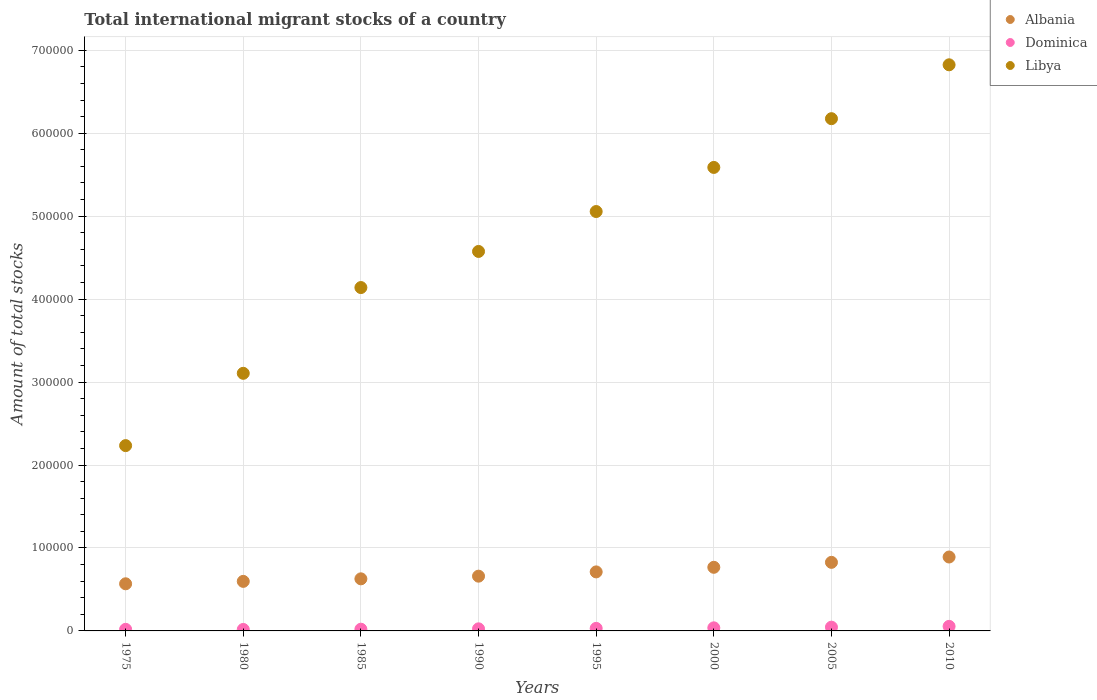How many different coloured dotlines are there?
Your answer should be compact. 3. What is the amount of total stocks in in Albania in 2000?
Offer a terse response. 7.67e+04. Across all years, what is the maximum amount of total stocks in in Albania?
Give a very brief answer. 8.91e+04. Across all years, what is the minimum amount of total stocks in in Albania?
Your answer should be very brief. 5.68e+04. In which year was the amount of total stocks in in Dominica maximum?
Ensure brevity in your answer.  2010. What is the total amount of total stocks in in Dominica in the graph?
Offer a terse response. 2.51e+04. What is the difference between the amount of total stocks in in Albania in 1975 and that in 1980?
Make the answer very short. -2914. What is the difference between the amount of total stocks in in Libya in 1985 and the amount of total stocks in in Albania in 1990?
Your response must be concise. 3.48e+05. What is the average amount of total stocks in in Dominica per year?
Your answer should be compact. 3136.75. In the year 1975, what is the difference between the amount of total stocks in in Albania and amount of total stocks in in Libya?
Offer a terse response. -1.67e+05. In how many years, is the amount of total stocks in in Dominica greater than 40000?
Your response must be concise. 0. What is the ratio of the amount of total stocks in in Dominica in 1980 to that in 1995?
Your answer should be very brief. 0.58. Is the amount of total stocks in in Libya in 1980 less than that in 2000?
Provide a short and direct response. Yes. Is the difference between the amount of total stocks in in Albania in 1985 and 2005 greater than the difference between the amount of total stocks in in Libya in 1985 and 2005?
Ensure brevity in your answer.  Yes. What is the difference between the highest and the second highest amount of total stocks in in Dominica?
Give a very brief answer. 975. What is the difference between the highest and the lowest amount of total stocks in in Libya?
Keep it short and to the point. 4.59e+05. Is it the case that in every year, the sum of the amount of total stocks in in Dominica and amount of total stocks in in Libya  is greater than the amount of total stocks in in Albania?
Your answer should be very brief. Yes. Does the amount of total stocks in in Albania monotonically increase over the years?
Offer a very short reply. Yes. Is the amount of total stocks in in Libya strictly greater than the amount of total stocks in in Dominica over the years?
Provide a short and direct response. Yes. Is the amount of total stocks in in Libya strictly less than the amount of total stocks in in Dominica over the years?
Provide a succinct answer. No. Are the values on the major ticks of Y-axis written in scientific E-notation?
Ensure brevity in your answer.  No. Does the graph contain grids?
Offer a terse response. Yes. Where does the legend appear in the graph?
Give a very brief answer. Top right. How many legend labels are there?
Give a very brief answer. 3. What is the title of the graph?
Offer a very short reply. Total international migrant stocks of a country. What is the label or title of the X-axis?
Provide a succinct answer. Years. What is the label or title of the Y-axis?
Your answer should be very brief. Amount of total stocks. What is the Amount of total stocks in Albania in 1975?
Ensure brevity in your answer.  5.68e+04. What is the Amount of total stocks in Dominica in 1975?
Your answer should be very brief. 1913. What is the Amount of total stocks of Libya in 1975?
Keep it short and to the point. 2.23e+05. What is the Amount of total stocks in Albania in 1980?
Ensure brevity in your answer.  5.97e+04. What is the Amount of total stocks of Dominica in 1980?
Provide a succinct answer. 1777. What is the Amount of total stocks in Libya in 1980?
Give a very brief answer. 3.11e+05. What is the Amount of total stocks of Albania in 1985?
Ensure brevity in your answer.  6.28e+04. What is the Amount of total stocks of Dominica in 1985?
Make the answer very short. 2072. What is the Amount of total stocks of Libya in 1985?
Your answer should be very brief. 4.14e+05. What is the Amount of total stocks of Albania in 1990?
Offer a very short reply. 6.60e+04. What is the Amount of total stocks of Dominica in 1990?
Provide a short and direct response. 2519. What is the Amount of total stocks of Libya in 1990?
Provide a succinct answer. 4.57e+05. What is the Amount of total stocks of Albania in 1995?
Your answer should be very brief. 7.12e+04. What is the Amount of total stocks of Dominica in 1995?
Provide a short and direct response. 3063. What is the Amount of total stocks in Libya in 1995?
Ensure brevity in your answer.  5.06e+05. What is the Amount of total stocks in Albania in 2000?
Give a very brief answer. 7.67e+04. What is the Amount of total stocks of Dominica in 2000?
Your answer should be compact. 3723. What is the Amount of total stocks in Libya in 2000?
Your answer should be compact. 5.59e+05. What is the Amount of total stocks in Albania in 2005?
Offer a very short reply. 8.27e+04. What is the Amount of total stocks in Dominica in 2005?
Provide a short and direct response. 4526. What is the Amount of total stocks of Libya in 2005?
Your answer should be compact. 6.18e+05. What is the Amount of total stocks of Albania in 2010?
Provide a short and direct response. 8.91e+04. What is the Amount of total stocks of Dominica in 2010?
Give a very brief answer. 5501. What is the Amount of total stocks of Libya in 2010?
Make the answer very short. 6.82e+05. Across all years, what is the maximum Amount of total stocks of Albania?
Provide a succinct answer. 8.91e+04. Across all years, what is the maximum Amount of total stocks of Dominica?
Your answer should be very brief. 5501. Across all years, what is the maximum Amount of total stocks of Libya?
Offer a very short reply. 6.82e+05. Across all years, what is the minimum Amount of total stocks in Albania?
Your response must be concise. 5.68e+04. Across all years, what is the minimum Amount of total stocks of Dominica?
Give a very brief answer. 1777. Across all years, what is the minimum Amount of total stocks of Libya?
Your answer should be compact. 2.23e+05. What is the total Amount of total stocks of Albania in the graph?
Give a very brief answer. 5.65e+05. What is the total Amount of total stocks in Dominica in the graph?
Your answer should be very brief. 2.51e+04. What is the total Amount of total stocks of Libya in the graph?
Provide a succinct answer. 3.77e+06. What is the difference between the Amount of total stocks of Albania in 1975 and that in 1980?
Ensure brevity in your answer.  -2914. What is the difference between the Amount of total stocks in Dominica in 1975 and that in 1980?
Your answer should be compact. 136. What is the difference between the Amount of total stocks of Libya in 1975 and that in 1980?
Your answer should be compact. -8.72e+04. What is the difference between the Amount of total stocks of Albania in 1975 and that in 1985?
Ensure brevity in your answer.  -5977. What is the difference between the Amount of total stocks in Dominica in 1975 and that in 1985?
Give a very brief answer. -159. What is the difference between the Amount of total stocks of Libya in 1975 and that in 1985?
Your answer should be compact. -1.91e+05. What is the difference between the Amount of total stocks in Albania in 1975 and that in 1990?
Offer a very short reply. -9197. What is the difference between the Amount of total stocks in Dominica in 1975 and that in 1990?
Your answer should be compact. -606. What is the difference between the Amount of total stocks in Libya in 1975 and that in 1990?
Your answer should be very brief. -2.34e+05. What is the difference between the Amount of total stocks of Albania in 1975 and that in 1995?
Provide a succinct answer. -1.43e+04. What is the difference between the Amount of total stocks in Dominica in 1975 and that in 1995?
Keep it short and to the point. -1150. What is the difference between the Amount of total stocks of Libya in 1975 and that in 1995?
Provide a succinct answer. -2.82e+05. What is the difference between the Amount of total stocks of Albania in 1975 and that in 2000?
Give a very brief answer. -1.99e+04. What is the difference between the Amount of total stocks of Dominica in 1975 and that in 2000?
Give a very brief answer. -1810. What is the difference between the Amount of total stocks in Libya in 1975 and that in 2000?
Offer a terse response. -3.35e+05. What is the difference between the Amount of total stocks of Albania in 1975 and that in 2005?
Your answer should be very brief. -2.59e+04. What is the difference between the Amount of total stocks in Dominica in 1975 and that in 2005?
Give a very brief answer. -2613. What is the difference between the Amount of total stocks of Libya in 1975 and that in 2005?
Give a very brief answer. -3.94e+05. What is the difference between the Amount of total stocks in Albania in 1975 and that in 2010?
Ensure brevity in your answer.  -3.23e+04. What is the difference between the Amount of total stocks of Dominica in 1975 and that in 2010?
Provide a succinct answer. -3588. What is the difference between the Amount of total stocks in Libya in 1975 and that in 2010?
Provide a succinct answer. -4.59e+05. What is the difference between the Amount of total stocks in Albania in 1980 and that in 1985?
Your response must be concise. -3063. What is the difference between the Amount of total stocks in Dominica in 1980 and that in 1985?
Your answer should be very brief. -295. What is the difference between the Amount of total stocks of Libya in 1980 and that in 1985?
Keep it short and to the point. -1.03e+05. What is the difference between the Amount of total stocks of Albania in 1980 and that in 1990?
Keep it short and to the point. -6283. What is the difference between the Amount of total stocks of Dominica in 1980 and that in 1990?
Offer a very short reply. -742. What is the difference between the Amount of total stocks of Libya in 1980 and that in 1990?
Make the answer very short. -1.47e+05. What is the difference between the Amount of total stocks of Albania in 1980 and that in 1995?
Your response must be concise. -1.14e+04. What is the difference between the Amount of total stocks in Dominica in 1980 and that in 1995?
Keep it short and to the point. -1286. What is the difference between the Amount of total stocks in Libya in 1980 and that in 1995?
Offer a terse response. -1.95e+05. What is the difference between the Amount of total stocks of Albania in 1980 and that in 2000?
Ensure brevity in your answer.  -1.70e+04. What is the difference between the Amount of total stocks in Dominica in 1980 and that in 2000?
Your answer should be very brief. -1946. What is the difference between the Amount of total stocks of Libya in 1980 and that in 2000?
Ensure brevity in your answer.  -2.48e+05. What is the difference between the Amount of total stocks of Albania in 1980 and that in 2005?
Keep it short and to the point. -2.29e+04. What is the difference between the Amount of total stocks in Dominica in 1980 and that in 2005?
Your answer should be compact. -2749. What is the difference between the Amount of total stocks of Libya in 1980 and that in 2005?
Give a very brief answer. -3.07e+05. What is the difference between the Amount of total stocks in Albania in 1980 and that in 2010?
Your answer should be very brief. -2.94e+04. What is the difference between the Amount of total stocks in Dominica in 1980 and that in 2010?
Make the answer very short. -3724. What is the difference between the Amount of total stocks of Libya in 1980 and that in 2010?
Your response must be concise. -3.72e+05. What is the difference between the Amount of total stocks in Albania in 1985 and that in 1990?
Ensure brevity in your answer.  -3220. What is the difference between the Amount of total stocks of Dominica in 1985 and that in 1990?
Give a very brief answer. -447. What is the difference between the Amount of total stocks in Libya in 1985 and that in 1990?
Your answer should be compact. -4.35e+04. What is the difference between the Amount of total stocks in Albania in 1985 and that in 1995?
Provide a short and direct response. -8361. What is the difference between the Amount of total stocks of Dominica in 1985 and that in 1995?
Make the answer very short. -991. What is the difference between the Amount of total stocks in Libya in 1985 and that in 1995?
Offer a terse response. -9.16e+04. What is the difference between the Amount of total stocks of Albania in 1985 and that in 2000?
Your response must be concise. -1.39e+04. What is the difference between the Amount of total stocks of Dominica in 1985 and that in 2000?
Your answer should be very brief. -1651. What is the difference between the Amount of total stocks of Libya in 1985 and that in 2000?
Your answer should be very brief. -1.45e+05. What is the difference between the Amount of total stocks in Albania in 1985 and that in 2005?
Provide a short and direct response. -1.99e+04. What is the difference between the Amount of total stocks in Dominica in 1985 and that in 2005?
Your answer should be very brief. -2454. What is the difference between the Amount of total stocks of Libya in 1985 and that in 2005?
Your answer should be compact. -2.04e+05. What is the difference between the Amount of total stocks in Albania in 1985 and that in 2010?
Keep it short and to the point. -2.63e+04. What is the difference between the Amount of total stocks of Dominica in 1985 and that in 2010?
Your answer should be very brief. -3429. What is the difference between the Amount of total stocks of Libya in 1985 and that in 2010?
Your response must be concise. -2.69e+05. What is the difference between the Amount of total stocks of Albania in 1990 and that in 1995?
Provide a short and direct response. -5141. What is the difference between the Amount of total stocks in Dominica in 1990 and that in 1995?
Your response must be concise. -544. What is the difference between the Amount of total stocks in Libya in 1990 and that in 1995?
Make the answer very short. -4.81e+04. What is the difference between the Amount of total stocks in Albania in 1990 and that in 2000?
Offer a terse response. -1.07e+04. What is the difference between the Amount of total stocks in Dominica in 1990 and that in 2000?
Offer a terse response. -1204. What is the difference between the Amount of total stocks in Libya in 1990 and that in 2000?
Give a very brief answer. -1.01e+05. What is the difference between the Amount of total stocks in Albania in 1990 and that in 2005?
Ensure brevity in your answer.  -1.67e+04. What is the difference between the Amount of total stocks in Dominica in 1990 and that in 2005?
Keep it short and to the point. -2007. What is the difference between the Amount of total stocks of Libya in 1990 and that in 2005?
Ensure brevity in your answer.  -1.60e+05. What is the difference between the Amount of total stocks in Albania in 1990 and that in 2010?
Ensure brevity in your answer.  -2.31e+04. What is the difference between the Amount of total stocks of Dominica in 1990 and that in 2010?
Offer a terse response. -2982. What is the difference between the Amount of total stocks of Libya in 1990 and that in 2010?
Your response must be concise. -2.25e+05. What is the difference between the Amount of total stocks of Albania in 1995 and that in 2000?
Provide a short and direct response. -5541. What is the difference between the Amount of total stocks in Dominica in 1995 and that in 2000?
Make the answer very short. -660. What is the difference between the Amount of total stocks of Libya in 1995 and that in 2000?
Keep it short and to the point. -5.32e+04. What is the difference between the Amount of total stocks of Albania in 1995 and that in 2005?
Make the answer very short. -1.15e+04. What is the difference between the Amount of total stocks of Dominica in 1995 and that in 2005?
Offer a terse response. -1463. What is the difference between the Amount of total stocks of Libya in 1995 and that in 2005?
Ensure brevity in your answer.  -1.12e+05. What is the difference between the Amount of total stocks of Albania in 1995 and that in 2010?
Your answer should be very brief. -1.80e+04. What is the difference between the Amount of total stocks in Dominica in 1995 and that in 2010?
Make the answer very short. -2438. What is the difference between the Amount of total stocks in Libya in 1995 and that in 2010?
Provide a succinct answer. -1.77e+05. What is the difference between the Amount of total stocks in Albania in 2000 and that in 2005?
Offer a terse response. -5973. What is the difference between the Amount of total stocks of Dominica in 2000 and that in 2005?
Keep it short and to the point. -803. What is the difference between the Amount of total stocks of Libya in 2000 and that in 2005?
Provide a short and direct response. -5.88e+04. What is the difference between the Amount of total stocks of Albania in 2000 and that in 2010?
Offer a very short reply. -1.24e+04. What is the difference between the Amount of total stocks in Dominica in 2000 and that in 2010?
Make the answer very short. -1778. What is the difference between the Amount of total stocks in Libya in 2000 and that in 2010?
Offer a terse response. -1.24e+05. What is the difference between the Amount of total stocks of Albania in 2005 and that in 2010?
Give a very brief answer. -6438. What is the difference between the Amount of total stocks in Dominica in 2005 and that in 2010?
Make the answer very short. -975. What is the difference between the Amount of total stocks in Libya in 2005 and that in 2010?
Give a very brief answer. -6.49e+04. What is the difference between the Amount of total stocks of Albania in 1975 and the Amount of total stocks of Dominica in 1980?
Ensure brevity in your answer.  5.50e+04. What is the difference between the Amount of total stocks of Albania in 1975 and the Amount of total stocks of Libya in 1980?
Your response must be concise. -2.54e+05. What is the difference between the Amount of total stocks of Dominica in 1975 and the Amount of total stocks of Libya in 1980?
Provide a succinct answer. -3.09e+05. What is the difference between the Amount of total stocks of Albania in 1975 and the Amount of total stocks of Dominica in 1985?
Your response must be concise. 5.47e+04. What is the difference between the Amount of total stocks of Albania in 1975 and the Amount of total stocks of Libya in 1985?
Offer a terse response. -3.57e+05. What is the difference between the Amount of total stocks in Dominica in 1975 and the Amount of total stocks in Libya in 1985?
Offer a very short reply. -4.12e+05. What is the difference between the Amount of total stocks in Albania in 1975 and the Amount of total stocks in Dominica in 1990?
Your answer should be compact. 5.43e+04. What is the difference between the Amount of total stocks in Albania in 1975 and the Amount of total stocks in Libya in 1990?
Give a very brief answer. -4.01e+05. What is the difference between the Amount of total stocks of Dominica in 1975 and the Amount of total stocks of Libya in 1990?
Give a very brief answer. -4.56e+05. What is the difference between the Amount of total stocks of Albania in 1975 and the Amount of total stocks of Dominica in 1995?
Your answer should be compact. 5.38e+04. What is the difference between the Amount of total stocks of Albania in 1975 and the Amount of total stocks of Libya in 1995?
Offer a very short reply. -4.49e+05. What is the difference between the Amount of total stocks of Dominica in 1975 and the Amount of total stocks of Libya in 1995?
Your response must be concise. -5.04e+05. What is the difference between the Amount of total stocks in Albania in 1975 and the Amount of total stocks in Dominica in 2000?
Your answer should be very brief. 5.31e+04. What is the difference between the Amount of total stocks in Albania in 1975 and the Amount of total stocks in Libya in 2000?
Make the answer very short. -5.02e+05. What is the difference between the Amount of total stocks of Dominica in 1975 and the Amount of total stocks of Libya in 2000?
Make the answer very short. -5.57e+05. What is the difference between the Amount of total stocks in Albania in 1975 and the Amount of total stocks in Dominica in 2005?
Provide a short and direct response. 5.23e+04. What is the difference between the Amount of total stocks of Albania in 1975 and the Amount of total stocks of Libya in 2005?
Offer a very short reply. -5.61e+05. What is the difference between the Amount of total stocks of Dominica in 1975 and the Amount of total stocks of Libya in 2005?
Make the answer very short. -6.16e+05. What is the difference between the Amount of total stocks of Albania in 1975 and the Amount of total stocks of Dominica in 2010?
Make the answer very short. 5.13e+04. What is the difference between the Amount of total stocks of Albania in 1975 and the Amount of total stocks of Libya in 2010?
Give a very brief answer. -6.26e+05. What is the difference between the Amount of total stocks in Dominica in 1975 and the Amount of total stocks in Libya in 2010?
Provide a succinct answer. -6.81e+05. What is the difference between the Amount of total stocks in Albania in 1980 and the Amount of total stocks in Dominica in 1985?
Give a very brief answer. 5.77e+04. What is the difference between the Amount of total stocks in Albania in 1980 and the Amount of total stocks in Libya in 1985?
Keep it short and to the point. -3.54e+05. What is the difference between the Amount of total stocks in Dominica in 1980 and the Amount of total stocks in Libya in 1985?
Provide a succinct answer. -4.12e+05. What is the difference between the Amount of total stocks in Albania in 1980 and the Amount of total stocks in Dominica in 1990?
Ensure brevity in your answer.  5.72e+04. What is the difference between the Amount of total stocks in Albania in 1980 and the Amount of total stocks in Libya in 1990?
Ensure brevity in your answer.  -3.98e+05. What is the difference between the Amount of total stocks of Dominica in 1980 and the Amount of total stocks of Libya in 1990?
Make the answer very short. -4.56e+05. What is the difference between the Amount of total stocks of Albania in 1980 and the Amount of total stocks of Dominica in 1995?
Your response must be concise. 5.67e+04. What is the difference between the Amount of total stocks in Albania in 1980 and the Amount of total stocks in Libya in 1995?
Make the answer very short. -4.46e+05. What is the difference between the Amount of total stocks of Dominica in 1980 and the Amount of total stocks of Libya in 1995?
Keep it short and to the point. -5.04e+05. What is the difference between the Amount of total stocks in Albania in 1980 and the Amount of total stocks in Dominica in 2000?
Your answer should be very brief. 5.60e+04. What is the difference between the Amount of total stocks in Albania in 1980 and the Amount of total stocks in Libya in 2000?
Ensure brevity in your answer.  -4.99e+05. What is the difference between the Amount of total stocks of Dominica in 1980 and the Amount of total stocks of Libya in 2000?
Ensure brevity in your answer.  -5.57e+05. What is the difference between the Amount of total stocks of Albania in 1980 and the Amount of total stocks of Dominica in 2005?
Provide a succinct answer. 5.52e+04. What is the difference between the Amount of total stocks of Albania in 1980 and the Amount of total stocks of Libya in 2005?
Your response must be concise. -5.58e+05. What is the difference between the Amount of total stocks of Dominica in 1980 and the Amount of total stocks of Libya in 2005?
Your response must be concise. -6.16e+05. What is the difference between the Amount of total stocks of Albania in 1980 and the Amount of total stocks of Dominica in 2010?
Offer a terse response. 5.42e+04. What is the difference between the Amount of total stocks in Albania in 1980 and the Amount of total stocks in Libya in 2010?
Provide a short and direct response. -6.23e+05. What is the difference between the Amount of total stocks in Dominica in 1980 and the Amount of total stocks in Libya in 2010?
Keep it short and to the point. -6.81e+05. What is the difference between the Amount of total stocks in Albania in 1985 and the Amount of total stocks in Dominica in 1990?
Provide a succinct answer. 6.03e+04. What is the difference between the Amount of total stocks of Albania in 1985 and the Amount of total stocks of Libya in 1990?
Your response must be concise. -3.95e+05. What is the difference between the Amount of total stocks of Dominica in 1985 and the Amount of total stocks of Libya in 1990?
Offer a terse response. -4.55e+05. What is the difference between the Amount of total stocks of Albania in 1985 and the Amount of total stocks of Dominica in 1995?
Your answer should be compact. 5.97e+04. What is the difference between the Amount of total stocks in Albania in 1985 and the Amount of total stocks in Libya in 1995?
Provide a succinct answer. -4.43e+05. What is the difference between the Amount of total stocks of Dominica in 1985 and the Amount of total stocks of Libya in 1995?
Ensure brevity in your answer.  -5.04e+05. What is the difference between the Amount of total stocks in Albania in 1985 and the Amount of total stocks in Dominica in 2000?
Your answer should be compact. 5.91e+04. What is the difference between the Amount of total stocks of Albania in 1985 and the Amount of total stocks of Libya in 2000?
Keep it short and to the point. -4.96e+05. What is the difference between the Amount of total stocks of Dominica in 1985 and the Amount of total stocks of Libya in 2000?
Give a very brief answer. -5.57e+05. What is the difference between the Amount of total stocks of Albania in 1985 and the Amount of total stocks of Dominica in 2005?
Provide a succinct answer. 5.83e+04. What is the difference between the Amount of total stocks in Albania in 1985 and the Amount of total stocks in Libya in 2005?
Make the answer very short. -5.55e+05. What is the difference between the Amount of total stocks in Dominica in 1985 and the Amount of total stocks in Libya in 2005?
Your answer should be very brief. -6.15e+05. What is the difference between the Amount of total stocks of Albania in 1985 and the Amount of total stocks of Dominica in 2010?
Keep it short and to the point. 5.73e+04. What is the difference between the Amount of total stocks in Albania in 1985 and the Amount of total stocks in Libya in 2010?
Make the answer very short. -6.20e+05. What is the difference between the Amount of total stocks in Dominica in 1985 and the Amount of total stocks in Libya in 2010?
Keep it short and to the point. -6.80e+05. What is the difference between the Amount of total stocks in Albania in 1990 and the Amount of total stocks in Dominica in 1995?
Ensure brevity in your answer.  6.30e+04. What is the difference between the Amount of total stocks of Albania in 1990 and the Amount of total stocks of Libya in 1995?
Give a very brief answer. -4.40e+05. What is the difference between the Amount of total stocks in Dominica in 1990 and the Amount of total stocks in Libya in 1995?
Your answer should be very brief. -5.03e+05. What is the difference between the Amount of total stocks in Albania in 1990 and the Amount of total stocks in Dominica in 2000?
Your response must be concise. 6.23e+04. What is the difference between the Amount of total stocks of Albania in 1990 and the Amount of total stocks of Libya in 2000?
Your answer should be very brief. -4.93e+05. What is the difference between the Amount of total stocks in Dominica in 1990 and the Amount of total stocks in Libya in 2000?
Keep it short and to the point. -5.56e+05. What is the difference between the Amount of total stocks of Albania in 1990 and the Amount of total stocks of Dominica in 2005?
Provide a succinct answer. 6.15e+04. What is the difference between the Amount of total stocks of Albania in 1990 and the Amount of total stocks of Libya in 2005?
Make the answer very short. -5.52e+05. What is the difference between the Amount of total stocks in Dominica in 1990 and the Amount of total stocks in Libya in 2005?
Ensure brevity in your answer.  -6.15e+05. What is the difference between the Amount of total stocks in Albania in 1990 and the Amount of total stocks in Dominica in 2010?
Your answer should be compact. 6.05e+04. What is the difference between the Amount of total stocks of Albania in 1990 and the Amount of total stocks of Libya in 2010?
Keep it short and to the point. -6.16e+05. What is the difference between the Amount of total stocks in Dominica in 1990 and the Amount of total stocks in Libya in 2010?
Your answer should be compact. -6.80e+05. What is the difference between the Amount of total stocks in Albania in 1995 and the Amount of total stocks in Dominica in 2000?
Offer a very short reply. 6.74e+04. What is the difference between the Amount of total stocks of Albania in 1995 and the Amount of total stocks of Libya in 2000?
Offer a very short reply. -4.88e+05. What is the difference between the Amount of total stocks of Dominica in 1995 and the Amount of total stocks of Libya in 2000?
Provide a succinct answer. -5.56e+05. What is the difference between the Amount of total stocks of Albania in 1995 and the Amount of total stocks of Dominica in 2005?
Keep it short and to the point. 6.66e+04. What is the difference between the Amount of total stocks of Albania in 1995 and the Amount of total stocks of Libya in 2005?
Your response must be concise. -5.46e+05. What is the difference between the Amount of total stocks of Dominica in 1995 and the Amount of total stocks of Libya in 2005?
Your answer should be compact. -6.14e+05. What is the difference between the Amount of total stocks of Albania in 1995 and the Amount of total stocks of Dominica in 2010?
Give a very brief answer. 6.57e+04. What is the difference between the Amount of total stocks of Albania in 1995 and the Amount of total stocks of Libya in 2010?
Your answer should be compact. -6.11e+05. What is the difference between the Amount of total stocks in Dominica in 1995 and the Amount of total stocks in Libya in 2010?
Your answer should be very brief. -6.79e+05. What is the difference between the Amount of total stocks in Albania in 2000 and the Amount of total stocks in Dominica in 2005?
Offer a very short reply. 7.22e+04. What is the difference between the Amount of total stocks in Albania in 2000 and the Amount of total stocks in Libya in 2005?
Your response must be concise. -5.41e+05. What is the difference between the Amount of total stocks in Dominica in 2000 and the Amount of total stocks in Libya in 2005?
Keep it short and to the point. -6.14e+05. What is the difference between the Amount of total stocks of Albania in 2000 and the Amount of total stocks of Dominica in 2010?
Offer a very short reply. 7.12e+04. What is the difference between the Amount of total stocks of Albania in 2000 and the Amount of total stocks of Libya in 2010?
Your answer should be compact. -6.06e+05. What is the difference between the Amount of total stocks in Dominica in 2000 and the Amount of total stocks in Libya in 2010?
Make the answer very short. -6.79e+05. What is the difference between the Amount of total stocks in Albania in 2005 and the Amount of total stocks in Dominica in 2010?
Make the answer very short. 7.72e+04. What is the difference between the Amount of total stocks of Albania in 2005 and the Amount of total stocks of Libya in 2010?
Keep it short and to the point. -6.00e+05. What is the difference between the Amount of total stocks in Dominica in 2005 and the Amount of total stocks in Libya in 2010?
Make the answer very short. -6.78e+05. What is the average Amount of total stocks of Albania per year?
Your response must be concise. 7.06e+04. What is the average Amount of total stocks in Dominica per year?
Offer a terse response. 3136.75. What is the average Amount of total stocks in Libya per year?
Give a very brief answer. 4.71e+05. In the year 1975, what is the difference between the Amount of total stocks in Albania and Amount of total stocks in Dominica?
Offer a terse response. 5.49e+04. In the year 1975, what is the difference between the Amount of total stocks in Albania and Amount of total stocks in Libya?
Your answer should be compact. -1.67e+05. In the year 1975, what is the difference between the Amount of total stocks of Dominica and Amount of total stocks of Libya?
Your answer should be very brief. -2.21e+05. In the year 1980, what is the difference between the Amount of total stocks of Albania and Amount of total stocks of Dominica?
Make the answer very short. 5.80e+04. In the year 1980, what is the difference between the Amount of total stocks of Albania and Amount of total stocks of Libya?
Your answer should be very brief. -2.51e+05. In the year 1980, what is the difference between the Amount of total stocks in Dominica and Amount of total stocks in Libya?
Your answer should be compact. -3.09e+05. In the year 1985, what is the difference between the Amount of total stocks of Albania and Amount of total stocks of Dominica?
Offer a terse response. 6.07e+04. In the year 1985, what is the difference between the Amount of total stocks in Albania and Amount of total stocks in Libya?
Offer a very short reply. -3.51e+05. In the year 1985, what is the difference between the Amount of total stocks in Dominica and Amount of total stocks in Libya?
Offer a terse response. -4.12e+05. In the year 1990, what is the difference between the Amount of total stocks of Albania and Amount of total stocks of Dominica?
Make the answer very short. 6.35e+04. In the year 1990, what is the difference between the Amount of total stocks in Albania and Amount of total stocks in Libya?
Offer a very short reply. -3.91e+05. In the year 1990, what is the difference between the Amount of total stocks in Dominica and Amount of total stocks in Libya?
Give a very brief answer. -4.55e+05. In the year 1995, what is the difference between the Amount of total stocks in Albania and Amount of total stocks in Dominica?
Offer a terse response. 6.81e+04. In the year 1995, what is the difference between the Amount of total stocks in Albania and Amount of total stocks in Libya?
Ensure brevity in your answer.  -4.34e+05. In the year 1995, what is the difference between the Amount of total stocks in Dominica and Amount of total stocks in Libya?
Your response must be concise. -5.03e+05. In the year 2000, what is the difference between the Amount of total stocks in Albania and Amount of total stocks in Dominica?
Ensure brevity in your answer.  7.30e+04. In the year 2000, what is the difference between the Amount of total stocks in Albania and Amount of total stocks in Libya?
Your answer should be very brief. -4.82e+05. In the year 2000, what is the difference between the Amount of total stocks in Dominica and Amount of total stocks in Libya?
Offer a very short reply. -5.55e+05. In the year 2005, what is the difference between the Amount of total stocks of Albania and Amount of total stocks of Dominica?
Make the answer very short. 7.81e+04. In the year 2005, what is the difference between the Amount of total stocks of Albania and Amount of total stocks of Libya?
Your response must be concise. -5.35e+05. In the year 2005, what is the difference between the Amount of total stocks in Dominica and Amount of total stocks in Libya?
Keep it short and to the point. -6.13e+05. In the year 2010, what is the difference between the Amount of total stocks of Albania and Amount of total stocks of Dominica?
Give a very brief answer. 8.36e+04. In the year 2010, what is the difference between the Amount of total stocks of Albania and Amount of total stocks of Libya?
Keep it short and to the point. -5.93e+05. In the year 2010, what is the difference between the Amount of total stocks in Dominica and Amount of total stocks in Libya?
Ensure brevity in your answer.  -6.77e+05. What is the ratio of the Amount of total stocks in Albania in 1975 to that in 1980?
Your response must be concise. 0.95. What is the ratio of the Amount of total stocks of Dominica in 1975 to that in 1980?
Ensure brevity in your answer.  1.08. What is the ratio of the Amount of total stocks of Libya in 1975 to that in 1980?
Provide a short and direct response. 0.72. What is the ratio of the Amount of total stocks in Albania in 1975 to that in 1985?
Provide a short and direct response. 0.9. What is the ratio of the Amount of total stocks of Dominica in 1975 to that in 1985?
Give a very brief answer. 0.92. What is the ratio of the Amount of total stocks in Libya in 1975 to that in 1985?
Your answer should be very brief. 0.54. What is the ratio of the Amount of total stocks of Albania in 1975 to that in 1990?
Offer a very short reply. 0.86. What is the ratio of the Amount of total stocks in Dominica in 1975 to that in 1990?
Your answer should be compact. 0.76. What is the ratio of the Amount of total stocks of Libya in 1975 to that in 1990?
Ensure brevity in your answer.  0.49. What is the ratio of the Amount of total stocks in Albania in 1975 to that in 1995?
Keep it short and to the point. 0.8. What is the ratio of the Amount of total stocks in Dominica in 1975 to that in 1995?
Your answer should be compact. 0.62. What is the ratio of the Amount of total stocks of Libya in 1975 to that in 1995?
Offer a terse response. 0.44. What is the ratio of the Amount of total stocks of Albania in 1975 to that in 2000?
Offer a very short reply. 0.74. What is the ratio of the Amount of total stocks of Dominica in 1975 to that in 2000?
Give a very brief answer. 0.51. What is the ratio of the Amount of total stocks in Libya in 1975 to that in 2000?
Your response must be concise. 0.4. What is the ratio of the Amount of total stocks in Albania in 1975 to that in 2005?
Keep it short and to the point. 0.69. What is the ratio of the Amount of total stocks of Dominica in 1975 to that in 2005?
Ensure brevity in your answer.  0.42. What is the ratio of the Amount of total stocks in Libya in 1975 to that in 2005?
Offer a terse response. 0.36. What is the ratio of the Amount of total stocks of Albania in 1975 to that in 2010?
Keep it short and to the point. 0.64. What is the ratio of the Amount of total stocks of Dominica in 1975 to that in 2010?
Keep it short and to the point. 0.35. What is the ratio of the Amount of total stocks of Libya in 1975 to that in 2010?
Offer a terse response. 0.33. What is the ratio of the Amount of total stocks of Albania in 1980 to that in 1985?
Provide a succinct answer. 0.95. What is the ratio of the Amount of total stocks of Dominica in 1980 to that in 1985?
Provide a short and direct response. 0.86. What is the ratio of the Amount of total stocks of Libya in 1980 to that in 1985?
Your answer should be compact. 0.75. What is the ratio of the Amount of total stocks of Albania in 1980 to that in 1990?
Your answer should be compact. 0.9. What is the ratio of the Amount of total stocks of Dominica in 1980 to that in 1990?
Offer a terse response. 0.71. What is the ratio of the Amount of total stocks in Libya in 1980 to that in 1990?
Give a very brief answer. 0.68. What is the ratio of the Amount of total stocks in Albania in 1980 to that in 1995?
Your answer should be compact. 0.84. What is the ratio of the Amount of total stocks of Dominica in 1980 to that in 1995?
Your response must be concise. 0.58. What is the ratio of the Amount of total stocks of Libya in 1980 to that in 1995?
Your answer should be compact. 0.61. What is the ratio of the Amount of total stocks in Albania in 1980 to that in 2000?
Your answer should be very brief. 0.78. What is the ratio of the Amount of total stocks of Dominica in 1980 to that in 2000?
Provide a succinct answer. 0.48. What is the ratio of the Amount of total stocks in Libya in 1980 to that in 2000?
Provide a short and direct response. 0.56. What is the ratio of the Amount of total stocks in Albania in 1980 to that in 2005?
Your answer should be very brief. 0.72. What is the ratio of the Amount of total stocks of Dominica in 1980 to that in 2005?
Your answer should be compact. 0.39. What is the ratio of the Amount of total stocks in Libya in 1980 to that in 2005?
Ensure brevity in your answer.  0.5. What is the ratio of the Amount of total stocks of Albania in 1980 to that in 2010?
Your response must be concise. 0.67. What is the ratio of the Amount of total stocks of Dominica in 1980 to that in 2010?
Give a very brief answer. 0.32. What is the ratio of the Amount of total stocks in Libya in 1980 to that in 2010?
Make the answer very short. 0.46. What is the ratio of the Amount of total stocks in Albania in 1985 to that in 1990?
Offer a terse response. 0.95. What is the ratio of the Amount of total stocks in Dominica in 1985 to that in 1990?
Offer a terse response. 0.82. What is the ratio of the Amount of total stocks of Libya in 1985 to that in 1990?
Ensure brevity in your answer.  0.9. What is the ratio of the Amount of total stocks of Albania in 1985 to that in 1995?
Your response must be concise. 0.88. What is the ratio of the Amount of total stocks in Dominica in 1985 to that in 1995?
Provide a short and direct response. 0.68. What is the ratio of the Amount of total stocks of Libya in 1985 to that in 1995?
Keep it short and to the point. 0.82. What is the ratio of the Amount of total stocks in Albania in 1985 to that in 2000?
Make the answer very short. 0.82. What is the ratio of the Amount of total stocks of Dominica in 1985 to that in 2000?
Your answer should be very brief. 0.56. What is the ratio of the Amount of total stocks in Libya in 1985 to that in 2000?
Keep it short and to the point. 0.74. What is the ratio of the Amount of total stocks of Albania in 1985 to that in 2005?
Give a very brief answer. 0.76. What is the ratio of the Amount of total stocks in Dominica in 1985 to that in 2005?
Provide a short and direct response. 0.46. What is the ratio of the Amount of total stocks of Libya in 1985 to that in 2005?
Your answer should be compact. 0.67. What is the ratio of the Amount of total stocks in Albania in 1985 to that in 2010?
Provide a succinct answer. 0.7. What is the ratio of the Amount of total stocks in Dominica in 1985 to that in 2010?
Offer a very short reply. 0.38. What is the ratio of the Amount of total stocks in Libya in 1985 to that in 2010?
Your response must be concise. 0.61. What is the ratio of the Amount of total stocks in Albania in 1990 to that in 1995?
Provide a short and direct response. 0.93. What is the ratio of the Amount of total stocks in Dominica in 1990 to that in 1995?
Your answer should be compact. 0.82. What is the ratio of the Amount of total stocks of Libya in 1990 to that in 1995?
Ensure brevity in your answer.  0.9. What is the ratio of the Amount of total stocks of Albania in 1990 to that in 2000?
Make the answer very short. 0.86. What is the ratio of the Amount of total stocks of Dominica in 1990 to that in 2000?
Keep it short and to the point. 0.68. What is the ratio of the Amount of total stocks of Libya in 1990 to that in 2000?
Give a very brief answer. 0.82. What is the ratio of the Amount of total stocks of Albania in 1990 to that in 2005?
Provide a succinct answer. 0.8. What is the ratio of the Amount of total stocks in Dominica in 1990 to that in 2005?
Provide a short and direct response. 0.56. What is the ratio of the Amount of total stocks in Libya in 1990 to that in 2005?
Ensure brevity in your answer.  0.74. What is the ratio of the Amount of total stocks in Albania in 1990 to that in 2010?
Your answer should be compact. 0.74. What is the ratio of the Amount of total stocks in Dominica in 1990 to that in 2010?
Offer a very short reply. 0.46. What is the ratio of the Amount of total stocks of Libya in 1990 to that in 2010?
Provide a short and direct response. 0.67. What is the ratio of the Amount of total stocks of Albania in 1995 to that in 2000?
Make the answer very short. 0.93. What is the ratio of the Amount of total stocks in Dominica in 1995 to that in 2000?
Your answer should be very brief. 0.82. What is the ratio of the Amount of total stocks in Libya in 1995 to that in 2000?
Offer a terse response. 0.9. What is the ratio of the Amount of total stocks of Albania in 1995 to that in 2005?
Your answer should be very brief. 0.86. What is the ratio of the Amount of total stocks of Dominica in 1995 to that in 2005?
Provide a short and direct response. 0.68. What is the ratio of the Amount of total stocks in Libya in 1995 to that in 2005?
Your answer should be compact. 0.82. What is the ratio of the Amount of total stocks of Albania in 1995 to that in 2010?
Provide a succinct answer. 0.8. What is the ratio of the Amount of total stocks of Dominica in 1995 to that in 2010?
Offer a terse response. 0.56. What is the ratio of the Amount of total stocks of Libya in 1995 to that in 2010?
Give a very brief answer. 0.74. What is the ratio of the Amount of total stocks in Albania in 2000 to that in 2005?
Provide a short and direct response. 0.93. What is the ratio of the Amount of total stocks of Dominica in 2000 to that in 2005?
Ensure brevity in your answer.  0.82. What is the ratio of the Amount of total stocks in Libya in 2000 to that in 2005?
Provide a short and direct response. 0.9. What is the ratio of the Amount of total stocks of Albania in 2000 to that in 2010?
Offer a very short reply. 0.86. What is the ratio of the Amount of total stocks of Dominica in 2000 to that in 2010?
Your answer should be very brief. 0.68. What is the ratio of the Amount of total stocks of Libya in 2000 to that in 2010?
Provide a succinct answer. 0.82. What is the ratio of the Amount of total stocks in Albania in 2005 to that in 2010?
Offer a terse response. 0.93. What is the ratio of the Amount of total stocks of Dominica in 2005 to that in 2010?
Ensure brevity in your answer.  0.82. What is the ratio of the Amount of total stocks in Libya in 2005 to that in 2010?
Provide a succinct answer. 0.9. What is the difference between the highest and the second highest Amount of total stocks of Albania?
Make the answer very short. 6438. What is the difference between the highest and the second highest Amount of total stocks in Dominica?
Offer a very short reply. 975. What is the difference between the highest and the second highest Amount of total stocks of Libya?
Give a very brief answer. 6.49e+04. What is the difference between the highest and the lowest Amount of total stocks of Albania?
Provide a succinct answer. 3.23e+04. What is the difference between the highest and the lowest Amount of total stocks of Dominica?
Provide a succinct answer. 3724. What is the difference between the highest and the lowest Amount of total stocks in Libya?
Your response must be concise. 4.59e+05. 